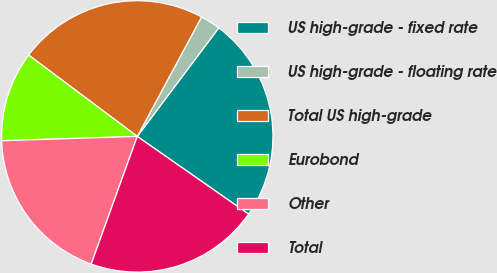<chart> <loc_0><loc_0><loc_500><loc_500><pie_chart><fcel>US high-grade - fixed rate<fcel>US high-grade - floating rate<fcel>Total US high-grade<fcel>Eurobond<fcel>Other<fcel>Total<nl><fcel>24.45%<fcel>2.39%<fcel>22.63%<fcel>10.74%<fcel>18.98%<fcel>20.81%<nl></chart> 